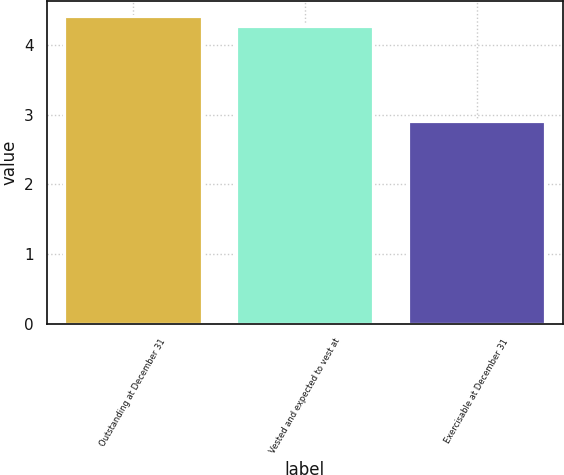Convert chart. <chart><loc_0><loc_0><loc_500><loc_500><bar_chart><fcel>Outstanding at December 31<fcel>Vested and expected to vest at<fcel>Exercisable at December 31<nl><fcel>4.41<fcel>4.27<fcel>2.9<nl></chart> 